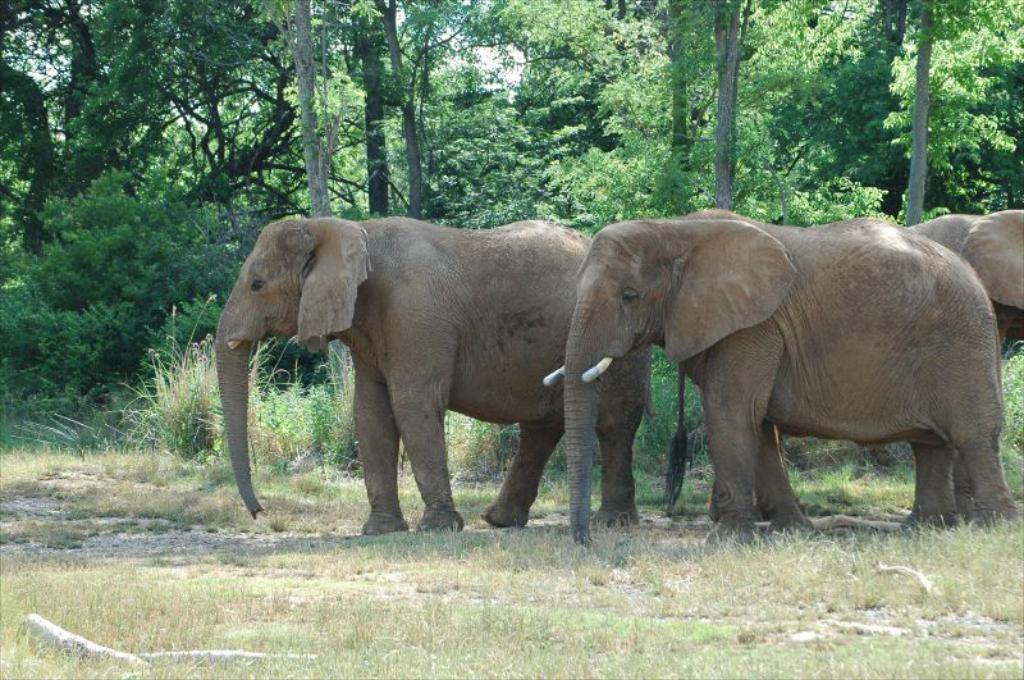What type of vegetation is present on the ground in the image? There is grass on the ground in the image. What animals can be seen on the right side of the image? There are elephants on the right side of the image. What can be seen in the distance in the image? There are many trees in the background of the image. What type of jeans are the brothers wearing in the image? There are no brothers or jeans present in the image. What type of tank can be seen in the image? There is no tank present in the image. 